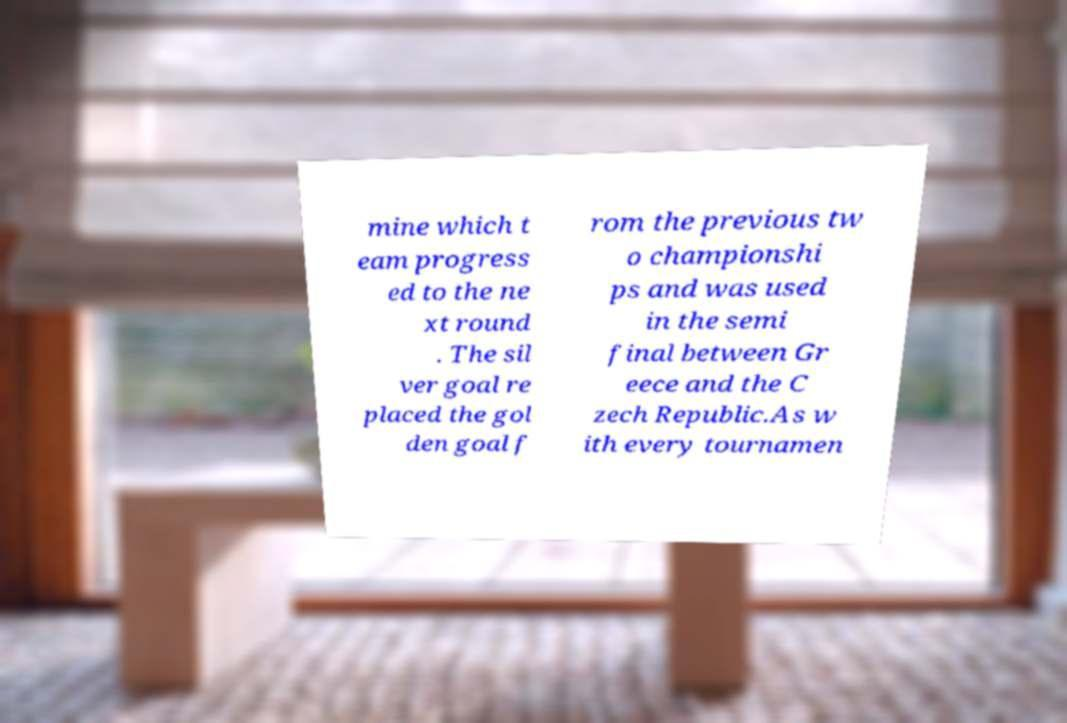Please read and relay the text visible in this image. What does it say? mine which t eam progress ed to the ne xt round . The sil ver goal re placed the gol den goal f rom the previous tw o championshi ps and was used in the semi final between Gr eece and the C zech Republic.As w ith every tournamen 